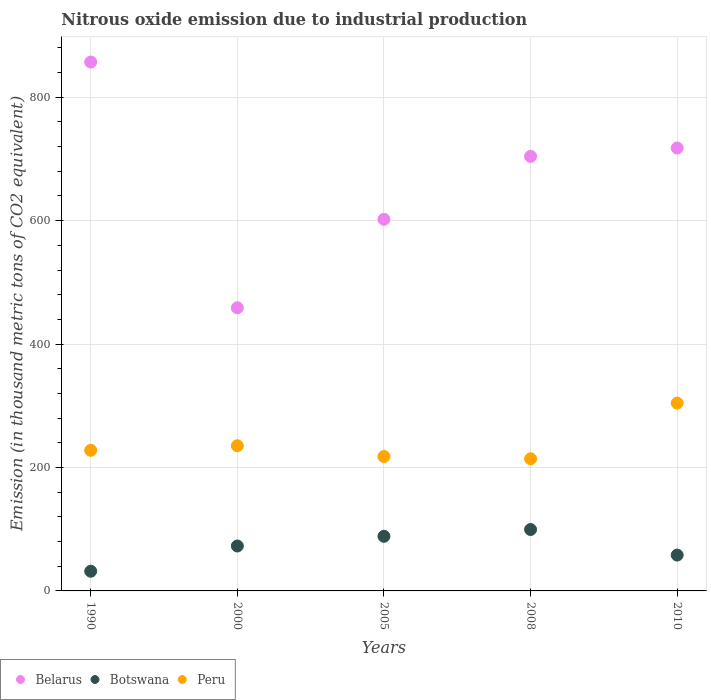Is the number of dotlines equal to the number of legend labels?
Provide a short and direct response. Yes. What is the amount of nitrous oxide emitted in Belarus in 2010?
Offer a terse response. 717.7. Across all years, what is the maximum amount of nitrous oxide emitted in Belarus?
Your answer should be very brief. 857. Across all years, what is the minimum amount of nitrous oxide emitted in Peru?
Your answer should be compact. 214.1. In which year was the amount of nitrous oxide emitted in Botswana maximum?
Make the answer very short. 2008. What is the total amount of nitrous oxide emitted in Botswana in the graph?
Offer a very short reply. 350.8. What is the difference between the amount of nitrous oxide emitted in Belarus in 1990 and that in 2008?
Keep it short and to the point. 152.9. What is the difference between the amount of nitrous oxide emitted in Peru in 2008 and the amount of nitrous oxide emitted in Botswana in 2010?
Offer a very short reply. 156. What is the average amount of nitrous oxide emitted in Botswana per year?
Your response must be concise. 70.16. In the year 2008, what is the difference between the amount of nitrous oxide emitted in Botswana and amount of nitrous oxide emitted in Belarus?
Your answer should be very brief. -604.6. What is the ratio of the amount of nitrous oxide emitted in Botswana in 2005 to that in 2008?
Provide a succinct answer. 0.89. Is the amount of nitrous oxide emitted in Peru in 2000 less than that in 2005?
Make the answer very short. No. What is the difference between the highest and the second highest amount of nitrous oxide emitted in Peru?
Offer a terse response. 69.2. What is the difference between the highest and the lowest amount of nitrous oxide emitted in Belarus?
Your answer should be very brief. 398.2. In how many years, is the amount of nitrous oxide emitted in Peru greater than the average amount of nitrous oxide emitted in Peru taken over all years?
Keep it short and to the point. 1. Is the sum of the amount of nitrous oxide emitted in Belarus in 1990 and 2005 greater than the maximum amount of nitrous oxide emitted in Botswana across all years?
Your answer should be very brief. Yes. Does the amount of nitrous oxide emitted in Belarus monotonically increase over the years?
Your answer should be compact. No. Is the amount of nitrous oxide emitted in Belarus strictly greater than the amount of nitrous oxide emitted in Botswana over the years?
Make the answer very short. Yes. Is the amount of nitrous oxide emitted in Peru strictly less than the amount of nitrous oxide emitted in Belarus over the years?
Your answer should be very brief. Yes. How many dotlines are there?
Offer a terse response. 3. How many years are there in the graph?
Make the answer very short. 5. Does the graph contain any zero values?
Give a very brief answer. No. Does the graph contain grids?
Offer a terse response. Yes. How many legend labels are there?
Your answer should be very brief. 3. How are the legend labels stacked?
Offer a very short reply. Horizontal. What is the title of the graph?
Make the answer very short. Nitrous oxide emission due to industrial production. What is the label or title of the Y-axis?
Provide a succinct answer. Emission (in thousand metric tons of CO2 equivalent). What is the Emission (in thousand metric tons of CO2 equivalent) in Belarus in 1990?
Offer a terse response. 857. What is the Emission (in thousand metric tons of CO2 equivalent) of Botswana in 1990?
Offer a terse response. 31.9. What is the Emission (in thousand metric tons of CO2 equivalent) in Peru in 1990?
Ensure brevity in your answer.  227.9. What is the Emission (in thousand metric tons of CO2 equivalent) of Belarus in 2000?
Your response must be concise. 458.8. What is the Emission (in thousand metric tons of CO2 equivalent) in Botswana in 2000?
Your response must be concise. 72.8. What is the Emission (in thousand metric tons of CO2 equivalent) of Peru in 2000?
Your answer should be compact. 235.2. What is the Emission (in thousand metric tons of CO2 equivalent) in Belarus in 2005?
Your answer should be very brief. 602.1. What is the Emission (in thousand metric tons of CO2 equivalent) in Botswana in 2005?
Offer a terse response. 88.5. What is the Emission (in thousand metric tons of CO2 equivalent) in Peru in 2005?
Your response must be concise. 217.8. What is the Emission (in thousand metric tons of CO2 equivalent) in Belarus in 2008?
Give a very brief answer. 704.1. What is the Emission (in thousand metric tons of CO2 equivalent) in Botswana in 2008?
Your answer should be compact. 99.5. What is the Emission (in thousand metric tons of CO2 equivalent) in Peru in 2008?
Ensure brevity in your answer.  214.1. What is the Emission (in thousand metric tons of CO2 equivalent) in Belarus in 2010?
Offer a terse response. 717.7. What is the Emission (in thousand metric tons of CO2 equivalent) of Botswana in 2010?
Your response must be concise. 58.1. What is the Emission (in thousand metric tons of CO2 equivalent) of Peru in 2010?
Offer a very short reply. 304.4. Across all years, what is the maximum Emission (in thousand metric tons of CO2 equivalent) of Belarus?
Your answer should be very brief. 857. Across all years, what is the maximum Emission (in thousand metric tons of CO2 equivalent) in Botswana?
Your answer should be very brief. 99.5. Across all years, what is the maximum Emission (in thousand metric tons of CO2 equivalent) in Peru?
Your answer should be compact. 304.4. Across all years, what is the minimum Emission (in thousand metric tons of CO2 equivalent) of Belarus?
Offer a very short reply. 458.8. Across all years, what is the minimum Emission (in thousand metric tons of CO2 equivalent) of Botswana?
Provide a short and direct response. 31.9. Across all years, what is the minimum Emission (in thousand metric tons of CO2 equivalent) of Peru?
Provide a succinct answer. 214.1. What is the total Emission (in thousand metric tons of CO2 equivalent) of Belarus in the graph?
Provide a short and direct response. 3339.7. What is the total Emission (in thousand metric tons of CO2 equivalent) in Botswana in the graph?
Offer a terse response. 350.8. What is the total Emission (in thousand metric tons of CO2 equivalent) of Peru in the graph?
Your answer should be compact. 1199.4. What is the difference between the Emission (in thousand metric tons of CO2 equivalent) in Belarus in 1990 and that in 2000?
Your answer should be compact. 398.2. What is the difference between the Emission (in thousand metric tons of CO2 equivalent) in Botswana in 1990 and that in 2000?
Your answer should be compact. -40.9. What is the difference between the Emission (in thousand metric tons of CO2 equivalent) of Peru in 1990 and that in 2000?
Make the answer very short. -7.3. What is the difference between the Emission (in thousand metric tons of CO2 equivalent) of Belarus in 1990 and that in 2005?
Provide a short and direct response. 254.9. What is the difference between the Emission (in thousand metric tons of CO2 equivalent) of Botswana in 1990 and that in 2005?
Your response must be concise. -56.6. What is the difference between the Emission (in thousand metric tons of CO2 equivalent) of Belarus in 1990 and that in 2008?
Your answer should be compact. 152.9. What is the difference between the Emission (in thousand metric tons of CO2 equivalent) of Botswana in 1990 and that in 2008?
Provide a short and direct response. -67.6. What is the difference between the Emission (in thousand metric tons of CO2 equivalent) of Peru in 1990 and that in 2008?
Your answer should be compact. 13.8. What is the difference between the Emission (in thousand metric tons of CO2 equivalent) of Belarus in 1990 and that in 2010?
Provide a succinct answer. 139.3. What is the difference between the Emission (in thousand metric tons of CO2 equivalent) in Botswana in 1990 and that in 2010?
Give a very brief answer. -26.2. What is the difference between the Emission (in thousand metric tons of CO2 equivalent) in Peru in 1990 and that in 2010?
Make the answer very short. -76.5. What is the difference between the Emission (in thousand metric tons of CO2 equivalent) of Belarus in 2000 and that in 2005?
Provide a short and direct response. -143.3. What is the difference between the Emission (in thousand metric tons of CO2 equivalent) in Botswana in 2000 and that in 2005?
Make the answer very short. -15.7. What is the difference between the Emission (in thousand metric tons of CO2 equivalent) in Belarus in 2000 and that in 2008?
Your response must be concise. -245.3. What is the difference between the Emission (in thousand metric tons of CO2 equivalent) of Botswana in 2000 and that in 2008?
Offer a very short reply. -26.7. What is the difference between the Emission (in thousand metric tons of CO2 equivalent) of Peru in 2000 and that in 2008?
Offer a terse response. 21.1. What is the difference between the Emission (in thousand metric tons of CO2 equivalent) in Belarus in 2000 and that in 2010?
Keep it short and to the point. -258.9. What is the difference between the Emission (in thousand metric tons of CO2 equivalent) of Botswana in 2000 and that in 2010?
Make the answer very short. 14.7. What is the difference between the Emission (in thousand metric tons of CO2 equivalent) of Peru in 2000 and that in 2010?
Provide a short and direct response. -69.2. What is the difference between the Emission (in thousand metric tons of CO2 equivalent) of Belarus in 2005 and that in 2008?
Ensure brevity in your answer.  -102. What is the difference between the Emission (in thousand metric tons of CO2 equivalent) in Belarus in 2005 and that in 2010?
Make the answer very short. -115.6. What is the difference between the Emission (in thousand metric tons of CO2 equivalent) of Botswana in 2005 and that in 2010?
Your response must be concise. 30.4. What is the difference between the Emission (in thousand metric tons of CO2 equivalent) of Peru in 2005 and that in 2010?
Give a very brief answer. -86.6. What is the difference between the Emission (in thousand metric tons of CO2 equivalent) of Belarus in 2008 and that in 2010?
Give a very brief answer. -13.6. What is the difference between the Emission (in thousand metric tons of CO2 equivalent) in Botswana in 2008 and that in 2010?
Your answer should be compact. 41.4. What is the difference between the Emission (in thousand metric tons of CO2 equivalent) in Peru in 2008 and that in 2010?
Offer a very short reply. -90.3. What is the difference between the Emission (in thousand metric tons of CO2 equivalent) in Belarus in 1990 and the Emission (in thousand metric tons of CO2 equivalent) in Botswana in 2000?
Offer a terse response. 784.2. What is the difference between the Emission (in thousand metric tons of CO2 equivalent) of Belarus in 1990 and the Emission (in thousand metric tons of CO2 equivalent) of Peru in 2000?
Give a very brief answer. 621.8. What is the difference between the Emission (in thousand metric tons of CO2 equivalent) in Botswana in 1990 and the Emission (in thousand metric tons of CO2 equivalent) in Peru in 2000?
Your response must be concise. -203.3. What is the difference between the Emission (in thousand metric tons of CO2 equivalent) in Belarus in 1990 and the Emission (in thousand metric tons of CO2 equivalent) in Botswana in 2005?
Your answer should be compact. 768.5. What is the difference between the Emission (in thousand metric tons of CO2 equivalent) in Belarus in 1990 and the Emission (in thousand metric tons of CO2 equivalent) in Peru in 2005?
Your answer should be very brief. 639.2. What is the difference between the Emission (in thousand metric tons of CO2 equivalent) of Botswana in 1990 and the Emission (in thousand metric tons of CO2 equivalent) of Peru in 2005?
Provide a succinct answer. -185.9. What is the difference between the Emission (in thousand metric tons of CO2 equivalent) of Belarus in 1990 and the Emission (in thousand metric tons of CO2 equivalent) of Botswana in 2008?
Keep it short and to the point. 757.5. What is the difference between the Emission (in thousand metric tons of CO2 equivalent) in Belarus in 1990 and the Emission (in thousand metric tons of CO2 equivalent) in Peru in 2008?
Make the answer very short. 642.9. What is the difference between the Emission (in thousand metric tons of CO2 equivalent) of Botswana in 1990 and the Emission (in thousand metric tons of CO2 equivalent) of Peru in 2008?
Give a very brief answer. -182.2. What is the difference between the Emission (in thousand metric tons of CO2 equivalent) of Belarus in 1990 and the Emission (in thousand metric tons of CO2 equivalent) of Botswana in 2010?
Offer a terse response. 798.9. What is the difference between the Emission (in thousand metric tons of CO2 equivalent) in Belarus in 1990 and the Emission (in thousand metric tons of CO2 equivalent) in Peru in 2010?
Your response must be concise. 552.6. What is the difference between the Emission (in thousand metric tons of CO2 equivalent) in Botswana in 1990 and the Emission (in thousand metric tons of CO2 equivalent) in Peru in 2010?
Your response must be concise. -272.5. What is the difference between the Emission (in thousand metric tons of CO2 equivalent) of Belarus in 2000 and the Emission (in thousand metric tons of CO2 equivalent) of Botswana in 2005?
Your answer should be compact. 370.3. What is the difference between the Emission (in thousand metric tons of CO2 equivalent) of Belarus in 2000 and the Emission (in thousand metric tons of CO2 equivalent) of Peru in 2005?
Keep it short and to the point. 241. What is the difference between the Emission (in thousand metric tons of CO2 equivalent) of Botswana in 2000 and the Emission (in thousand metric tons of CO2 equivalent) of Peru in 2005?
Provide a short and direct response. -145. What is the difference between the Emission (in thousand metric tons of CO2 equivalent) in Belarus in 2000 and the Emission (in thousand metric tons of CO2 equivalent) in Botswana in 2008?
Provide a succinct answer. 359.3. What is the difference between the Emission (in thousand metric tons of CO2 equivalent) of Belarus in 2000 and the Emission (in thousand metric tons of CO2 equivalent) of Peru in 2008?
Offer a very short reply. 244.7. What is the difference between the Emission (in thousand metric tons of CO2 equivalent) in Botswana in 2000 and the Emission (in thousand metric tons of CO2 equivalent) in Peru in 2008?
Offer a very short reply. -141.3. What is the difference between the Emission (in thousand metric tons of CO2 equivalent) of Belarus in 2000 and the Emission (in thousand metric tons of CO2 equivalent) of Botswana in 2010?
Your response must be concise. 400.7. What is the difference between the Emission (in thousand metric tons of CO2 equivalent) in Belarus in 2000 and the Emission (in thousand metric tons of CO2 equivalent) in Peru in 2010?
Make the answer very short. 154.4. What is the difference between the Emission (in thousand metric tons of CO2 equivalent) of Botswana in 2000 and the Emission (in thousand metric tons of CO2 equivalent) of Peru in 2010?
Provide a short and direct response. -231.6. What is the difference between the Emission (in thousand metric tons of CO2 equivalent) of Belarus in 2005 and the Emission (in thousand metric tons of CO2 equivalent) of Botswana in 2008?
Ensure brevity in your answer.  502.6. What is the difference between the Emission (in thousand metric tons of CO2 equivalent) of Belarus in 2005 and the Emission (in thousand metric tons of CO2 equivalent) of Peru in 2008?
Your answer should be very brief. 388. What is the difference between the Emission (in thousand metric tons of CO2 equivalent) of Botswana in 2005 and the Emission (in thousand metric tons of CO2 equivalent) of Peru in 2008?
Offer a very short reply. -125.6. What is the difference between the Emission (in thousand metric tons of CO2 equivalent) in Belarus in 2005 and the Emission (in thousand metric tons of CO2 equivalent) in Botswana in 2010?
Keep it short and to the point. 544. What is the difference between the Emission (in thousand metric tons of CO2 equivalent) of Belarus in 2005 and the Emission (in thousand metric tons of CO2 equivalent) of Peru in 2010?
Your answer should be very brief. 297.7. What is the difference between the Emission (in thousand metric tons of CO2 equivalent) of Botswana in 2005 and the Emission (in thousand metric tons of CO2 equivalent) of Peru in 2010?
Your response must be concise. -215.9. What is the difference between the Emission (in thousand metric tons of CO2 equivalent) of Belarus in 2008 and the Emission (in thousand metric tons of CO2 equivalent) of Botswana in 2010?
Your answer should be very brief. 646. What is the difference between the Emission (in thousand metric tons of CO2 equivalent) of Belarus in 2008 and the Emission (in thousand metric tons of CO2 equivalent) of Peru in 2010?
Ensure brevity in your answer.  399.7. What is the difference between the Emission (in thousand metric tons of CO2 equivalent) of Botswana in 2008 and the Emission (in thousand metric tons of CO2 equivalent) of Peru in 2010?
Provide a succinct answer. -204.9. What is the average Emission (in thousand metric tons of CO2 equivalent) of Belarus per year?
Your response must be concise. 667.94. What is the average Emission (in thousand metric tons of CO2 equivalent) of Botswana per year?
Your answer should be compact. 70.16. What is the average Emission (in thousand metric tons of CO2 equivalent) in Peru per year?
Your answer should be very brief. 239.88. In the year 1990, what is the difference between the Emission (in thousand metric tons of CO2 equivalent) in Belarus and Emission (in thousand metric tons of CO2 equivalent) in Botswana?
Provide a short and direct response. 825.1. In the year 1990, what is the difference between the Emission (in thousand metric tons of CO2 equivalent) in Belarus and Emission (in thousand metric tons of CO2 equivalent) in Peru?
Your answer should be very brief. 629.1. In the year 1990, what is the difference between the Emission (in thousand metric tons of CO2 equivalent) in Botswana and Emission (in thousand metric tons of CO2 equivalent) in Peru?
Your response must be concise. -196. In the year 2000, what is the difference between the Emission (in thousand metric tons of CO2 equivalent) in Belarus and Emission (in thousand metric tons of CO2 equivalent) in Botswana?
Keep it short and to the point. 386. In the year 2000, what is the difference between the Emission (in thousand metric tons of CO2 equivalent) in Belarus and Emission (in thousand metric tons of CO2 equivalent) in Peru?
Your answer should be compact. 223.6. In the year 2000, what is the difference between the Emission (in thousand metric tons of CO2 equivalent) in Botswana and Emission (in thousand metric tons of CO2 equivalent) in Peru?
Your answer should be very brief. -162.4. In the year 2005, what is the difference between the Emission (in thousand metric tons of CO2 equivalent) of Belarus and Emission (in thousand metric tons of CO2 equivalent) of Botswana?
Provide a succinct answer. 513.6. In the year 2005, what is the difference between the Emission (in thousand metric tons of CO2 equivalent) of Belarus and Emission (in thousand metric tons of CO2 equivalent) of Peru?
Your answer should be compact. 384.3. In the year 2005, what is the difference between the Emission (in thousand metric tons of CO2 equivalent) in Botswana and Emission (in thousand metric tons of CO2 equivalent) in Peru?
Offer a terse response. -129.3. In the year 2008, what is the difference between the Emission (in thousand metric tons of CO2 equivalent) in Belarus and Emission (in thousand metric tons of CO2 equivalent) in Botswana?
Your answer should be compact. 604.6. In the year 2008, what is the difference between the Emission (in thousand metric tons of CO2 equivalent) in Belarus and Emission (in thousand metric tons of CO2 equivalent) in Peru?
Provide a succinct answer. 490. In the year 2008, what is the difference between the Emission (in thousand metric tons of CO2 equivalent) of Botswana and Emission (in thousand metric tons of CO2 equivalent) of Peru?
Offer a terse response. -114.6. In the year 2010, what is the difference between the Emission (in thousand metric tons of CO2 equivalent) of Belarus and Emission (in thousand metric tons of CO2 equivalent) of Botswana?
Your answer should be compact. 659.6. In the year 2010, what is the difference between the Emission (in thousand metric tons of CO2 equivalent) in Belarus and Emission (in thousand metric tons of CO2 equivalent) in Peru?
Keep it short and to the point. 413.3. In the year 2010, what is the difference between the Emission (in thousand metric tons of CO2 equivalent) in Botswana and Emission (in thousand metric tons of CO2 equivalent) in Peru?
Your response must be concise. -246.3. What is the ratio of the Emission (in thousand metric tons of CO2 equivalent) in Belarus in 1990 to that in 2000?
Keep it short and to the point. 1.87. What is the ratio of the Emission (in thousand metric tons of CO2 equivalent) of Botswana in 1990 to that in 2000?
Provide a short and direct response. 0.44. What is the ratio of the Emission (in thousand metric tons of CO2 equivalent) of Peru in 1990 to that in 2000?
Your answer should be compact. 0.97. What is the ratio of the Emission (in thousand metric tons of CO2 equivalent) of Belarus in 1990 to that in 2005?
Your answer should be compact. 1.42. What is the ratio of the Emission (in thousand metric tons of CO2 equivalent) in Botswana in 1990 to that in 2005?
Give a very brief answer. 0.36. What is the ratio of the Emission (in thousand metric tons of CO2 equivalent) in Peru in 1990 to that in 2005?
Your answer should be compact. 1.05. What is the ratio of the Emission (in thousand metric tons of CO2 equivalent) of Belarus in 1990 to that in 2008?
Provide a short and direct response. 1.22. What is the ratio of the Emission (in thousand metric tons of CO2 equivalent) of Botswana in 1990 to that in 2008?
Your answer should be compact. 0.32. What is the ratio of the Emission (in thousand metric tons of CO2 equivalent) of Peru in 1990 to that in 2008?
Give a very brief answer. 1.06. What is the ratio of the Emission (in thousand metric tons of CO2 equivalent) of Belarus in 1990 to that in 2010?
Provide a short and direct response. 1.19. What is the ratio of the Emission (in thousand metric tons of CO2 equivalent) of Botswana in 1990 to that in 2010?
Ensure brevity in your answer.  0.55. What is the ratio of the Emission (in thousand metric tons of CO2 equivalent) of Peru in 1990 to that in 2010?
Ensure brevity in your answer.  0.75. What is the ratio of the Emission (in thousand metric tons of CO2 equivalent) in Belarus in 2000 to that in 2005?
Your answer should be compact. 0.76. What is the ratio of the Emission (in thousand metric tons of CO2 equivalent) of Botswana in 2000 to that in 2005?
Provide a short and direct response. 0.82. What is the ratio of the Emission (in thousand metric tons of CO2 equivalent) of Peru in 2000 to that in 2005?
Give a very brief answer. 1.08. What is the ratio of the Emission (in thousand metric tons of CO2 equivalent) in Belarus in 2000 to that in 2008?
Your answer should be very brief. 0.65. What is the ratio of the Emission (in thousand metric tons of CO2 equivalent) of Botswana in 2000 to that in 2008?
Offer a very short reply. 0.73. What is the ratio of the Emission (in thousand metric tons of CO2 equivalent) in Peru in 2000 to that in 2008?
Provide a short and direct response. 1.1. What is the ratio of the Emission (in thousand metric tons of CO2 equivalent) in Belarus in 2000 to that in 2010?
Keep it short and to the point. 0.64. What is the ratio of the Emission (in thousand metric tons of CO2 equivalent) in Botswana in 2000 to that in 2010?
Make the answer very short. 1.25. What is the ratio of the Emission (in thousand metric tons of CO2 equivalent) of Peru in 2000 to that in 2010?
Provide a short and direct response. 0.77. What is the ratio of the Emission (in thousand metric tons of CO2 equivalent) of Belarus in 2005 to that in 2008?
Your response must be concise. 0.86. What is the ratio of the Emission (in thousand metric tons of CO2 equivalent) of Botswana in 2005 to that in 2008?
Offer a terse response. 0.89. What is the ratio of the Emission (in thousand metric tons of CO2 equivalent) in Peru in 2005 to that in 2008?
Offer a terse response. 1.02. What is the ratio of the Emission (in thousand metric tons of CO2 equivalent) in Belarus in 2005 to that in 2010?
Offer a very short reply. 0.84. What is the ratio of the Emission (in thousand metric tons of CO2 equivalent) in Botswana in 2005 to that in 2010?
Make the answer very short. 1.52. What is the ratio of the Emission (in thousand metric tons of CO2 equivalent) of Peru in 2005 to that in 2010?
Your answer should be compact. 0.72. What is the ratio of the Emission (in thousand metric tons of CO2 equivalent) in Belarus in 2008 to that in 2010?
Provide a short and direct response. 0.98. What is the ratio of the Emission (in thousand metric tons of CO2 equivalent) in Botswana in 2008 to that in 2010?
Make the answer very short. 1.71. What is the ratio of the Emission (in thousand metric tons of CO2 equivalent) in Peru in 2008 to that in 2010?
Keep it short and to the point. 0.7. What is the difference between the highest and the second highest Emission (in thousand metric tons of CO2 equivalent) in Belarus?
Give a very brief answer. 139.3. What is the difference between the highest and the second highest Emission (in thousand metric tons of CO2 equivalent) in Botswana?
Ensure brevity in your answer.  11. What is the difference between the highest and the second highest Emission (in thousand metric tons of CO2 equivalent) of Peru?
Give a very brief answer. 69.2. What is the difference between the highest and the lowest Emission (in thousand metric tons of CO2 equivalent) of Belarus?
Offer a very short reply. 398.2. What is the difference between the highest and the lowest Emission (in thousand metric tons of CO2 equivalent) in Botswana?
Your answer should be compact. 67.6. What is the difference between the highest and the lowest Emission (in thousand metric tons of CO2 equivalent) of Peru?
Your answer should be very brief. 90.3. 